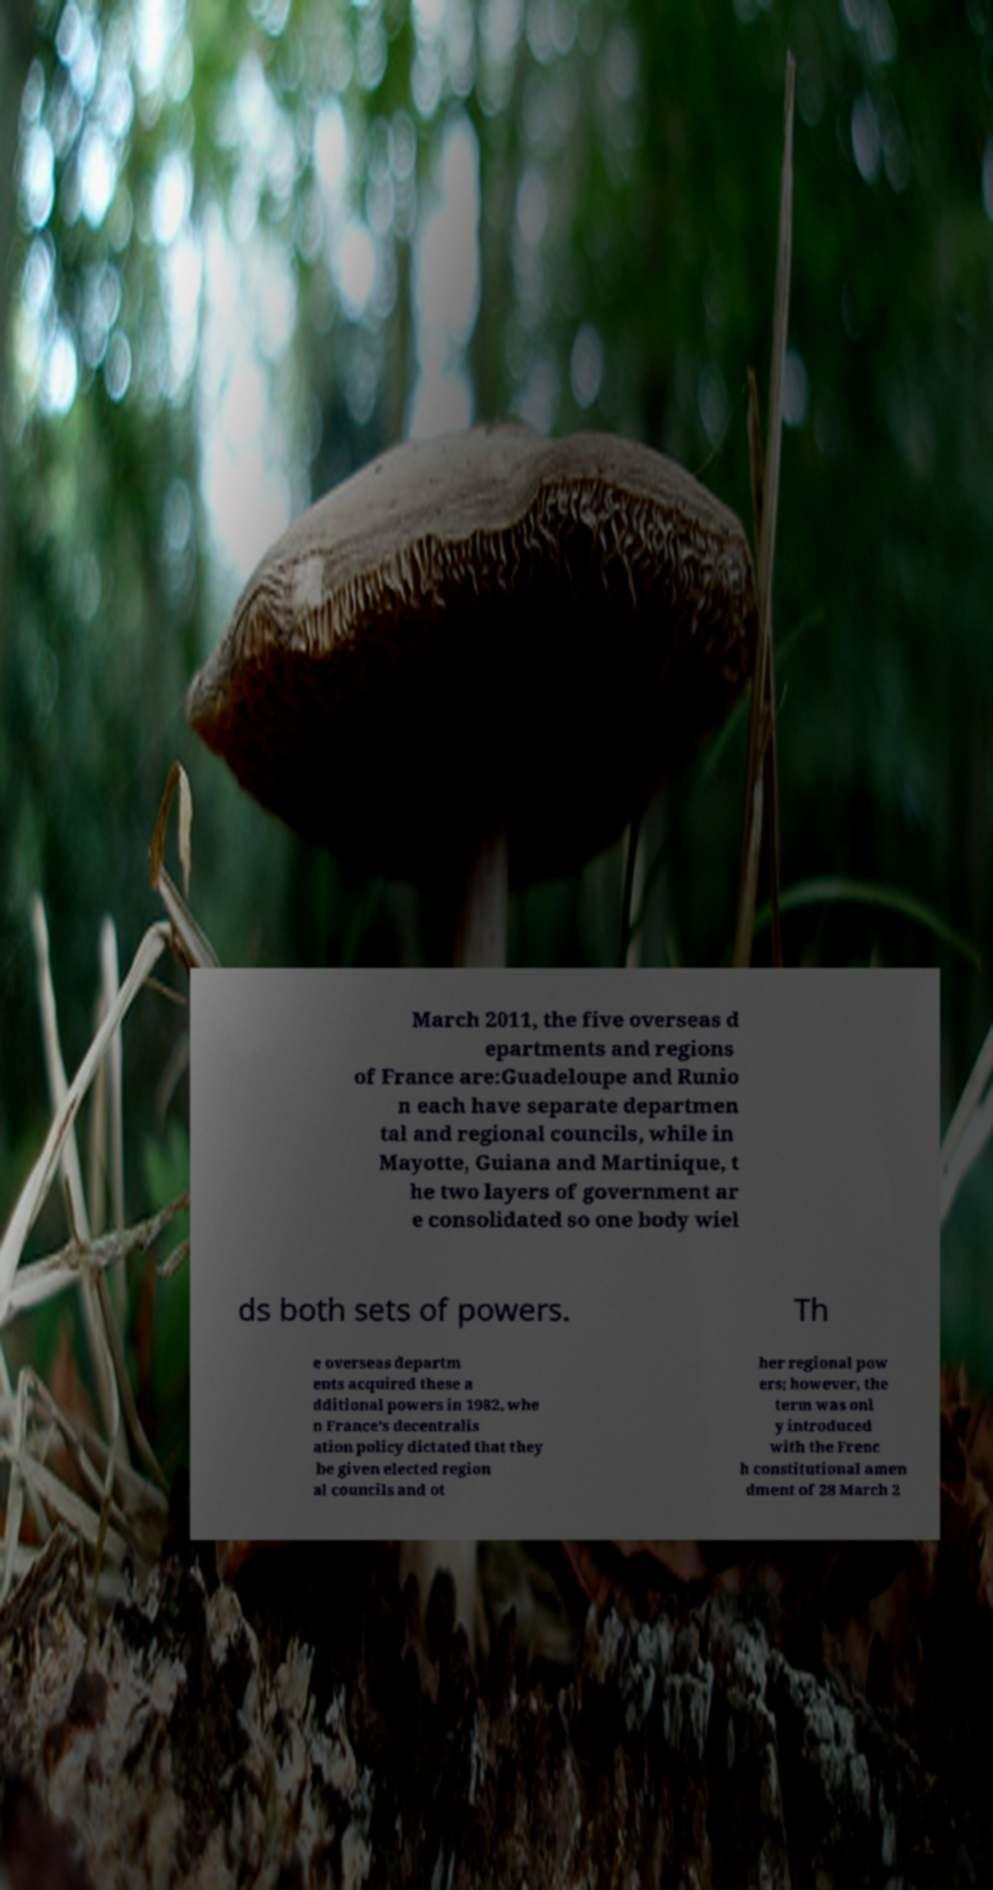Could you assist in decoding the text presented in this image and type it out clearly? March 2011, the five overseas d epartments and regions of France are:Guadeloupe and Runio n each have separate departmen tal and regional councils, while in Mayotte, Guiana and Martinique, t he two layers of government ar e consolidated so one body wiel ds both sets of powers. Th e overseas departm ents acquired these a dditional powers in 1982, whe n France's decentralis ation policy dictated that they be given elected region al councils and ot her regional pow ers; however, the term was onl y introduced with the Frenc h constitutional amen dment of 28 March 2 